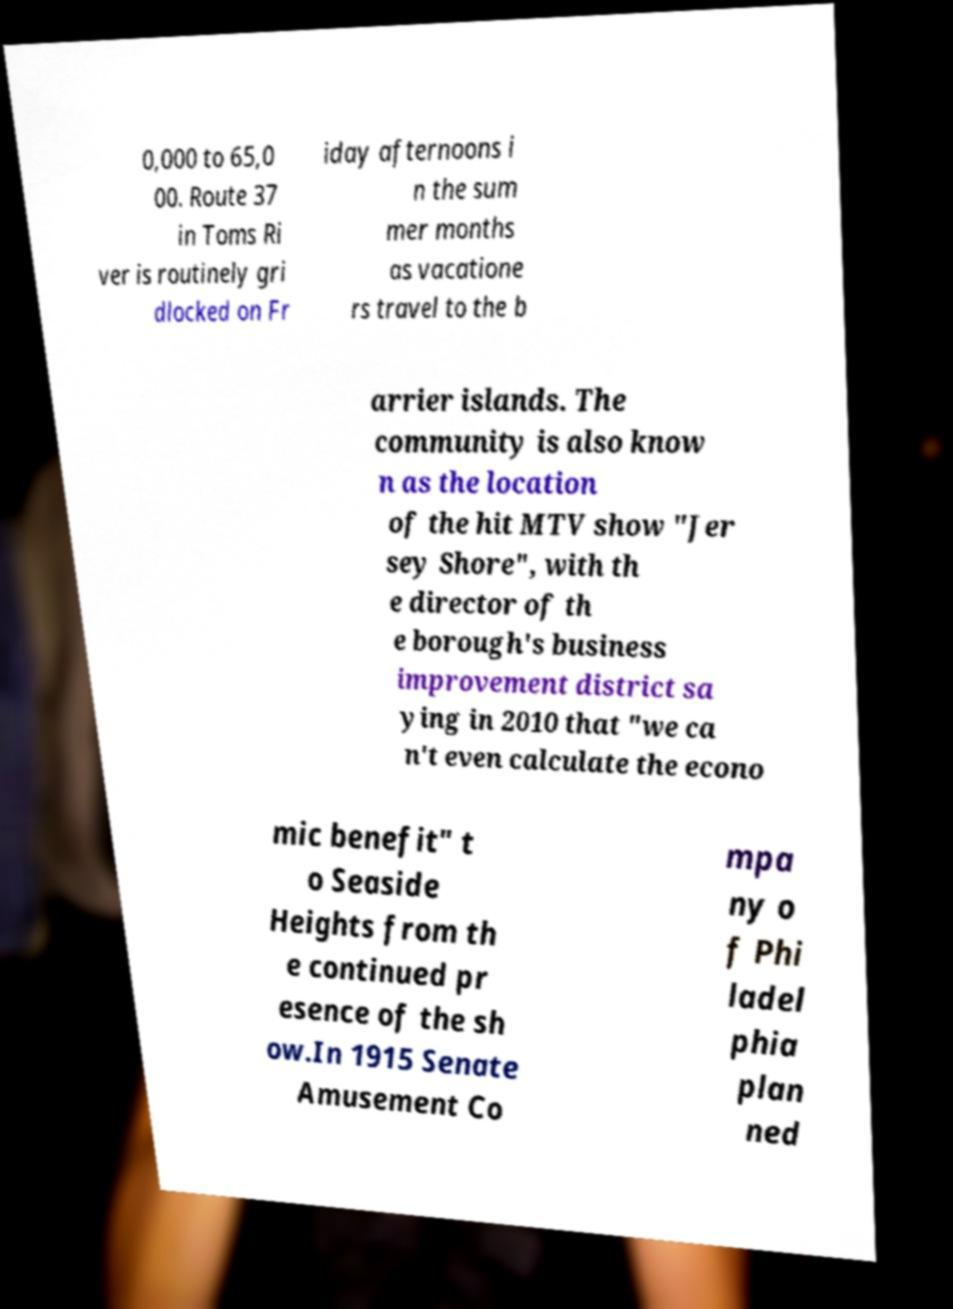Could you assist in decoding the text presented in this image and type it out clearly? 0,000 to 65,0 00. Route 37 in Toms Ri ver is routinely gri dlocked on Fr iday afternoons i n the sum mer months as vacatione rs travel to the b arrier islands. The community is also know n as the location of the hit MTV show "Jer sey Shore", with th e director of th e borough's business improvement district sa ying in 2010 that "we ca n't even calculate the econo mic benefit" t o Seaside Heights from th e continued pr esence of the sh ow.In 1915 Senate Amusement Co mpa ny o f Phi ladel phia plan ned 